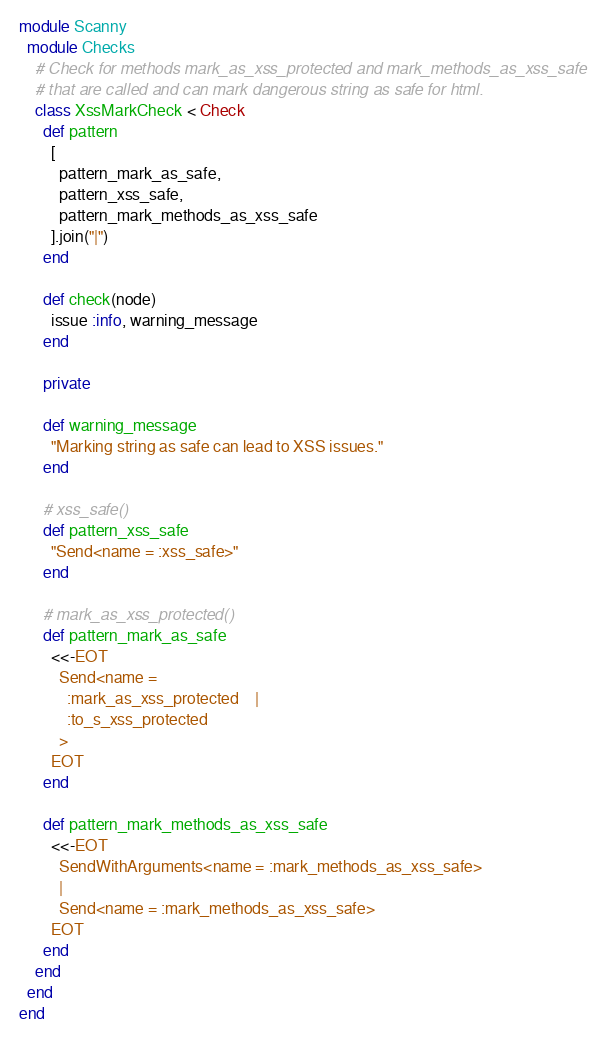<code> <loc_0><loc_0><loc_500><loc_500><_Ruby_>module Scanny
  module Checks
    # Check for methods mark_as_xss_protected and mark_methods_as_xss_safe
    # that are called and can mark dangerous string as safe for html.
    class XssMarkCheck < Check
      def pattern
        [
          pattern_mark_as_safe,
          pattern_xss_safe,
          pattern_mark_methods_as_xss_safe
        ].join("|")
      end

      def check(node)
        issue :info, warning_message
      end

      private

      def warning_message
        "Marking string as safe can lead to XSS issues."
      end

      # xss_safe()
      def pattern_xss_safe
        "Send<name = :xss_safe>"
      end

      # mark_as_xss_protected()
      def pattern_mark_as_safe
        <<-EOT
          Send<name =
            :mark_as_xss_protected    |
            :to_s_xss_protected
          >
        EOT
      end

      def pattern_mark_methods_as_xss_safe
        <<-EOT
          SendWithArguments<name = :mark_methods_as_xss_safe>
          |
          Send<name = :mark_methods_as_xss_safe>
        EOT
      end
    end
  end
end</code> 